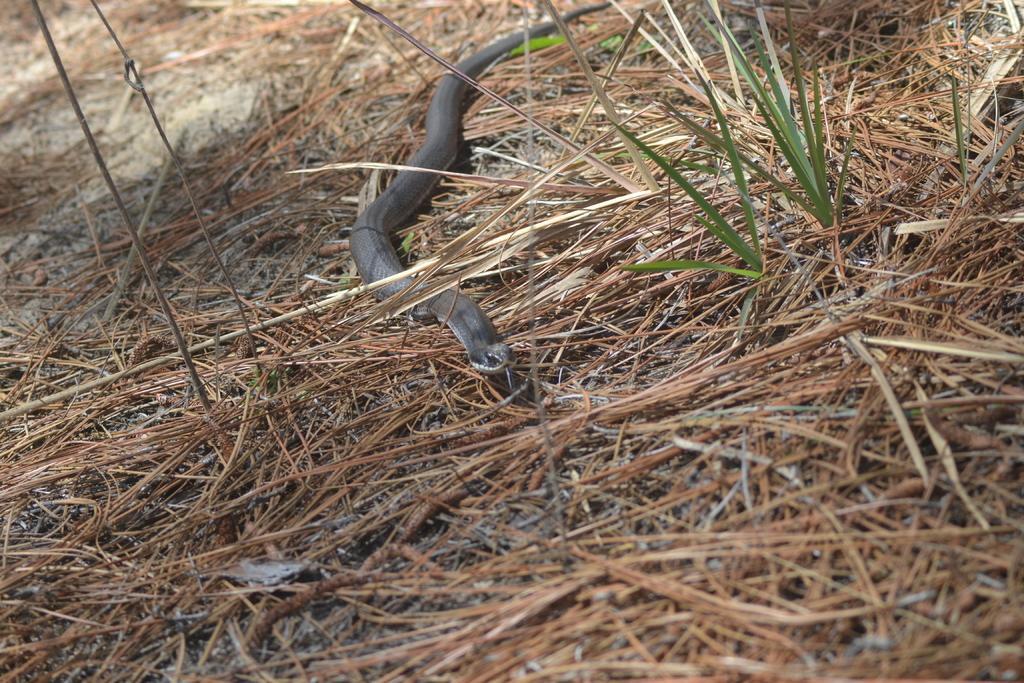How would you summarize this image in a sentence or two? This picture shows a snake on the ground and we see grass. 